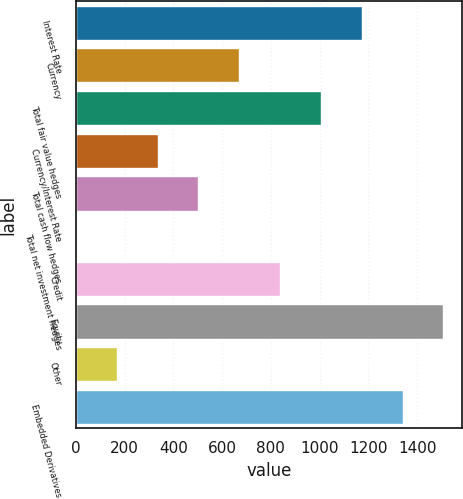Convert chart to OTSL. <chart><loc_0><loc_0><loc_500><loc_500><bar_chart><fcel>Interest Rate<fcel>Currency<fcel>Total fair value hedges<fcel>Currency/Interest Rate<fcel>Total cash flow hedges<fcel>Total net investment hedges<fcel>Credit<fcel>Equity<fcel>Other<fcel>Embedded Derivatives<nl><fcel>1172.78<fcel>670.53<fcel>1005.36<fcel>335.69<fcel>503.11<fcel>0.85<fcel>837.94<fcel>1507.61<fcel>168.27<fcel>1340.19<nl></chart> 